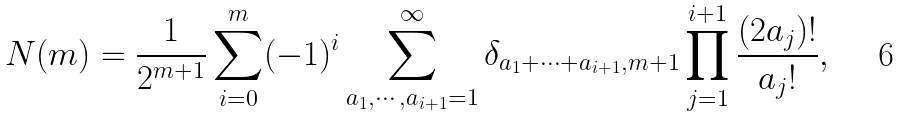Convert formula to latex. <formula><loc_0><loc_0><loc_500><loc_500>N ( m ) = \frac { 1 } { 2 ^ { m + 1 } } \sum _ { i = 0 } ^ { m } ( - 1 ) ^ { i } \sum _ { a _ { 1 } , \cdots , a _ { i + 1 } = 1 } ^ { \infty } \delta _ { a _ { 1 } + \cdots + a _ { i + 1 } , m + 1 } \prod _ { j = 1 } ^ { i + 1 } \frac { ( 2 a _ { j } ) ! } { a _ { j } ! } ,</formula> 